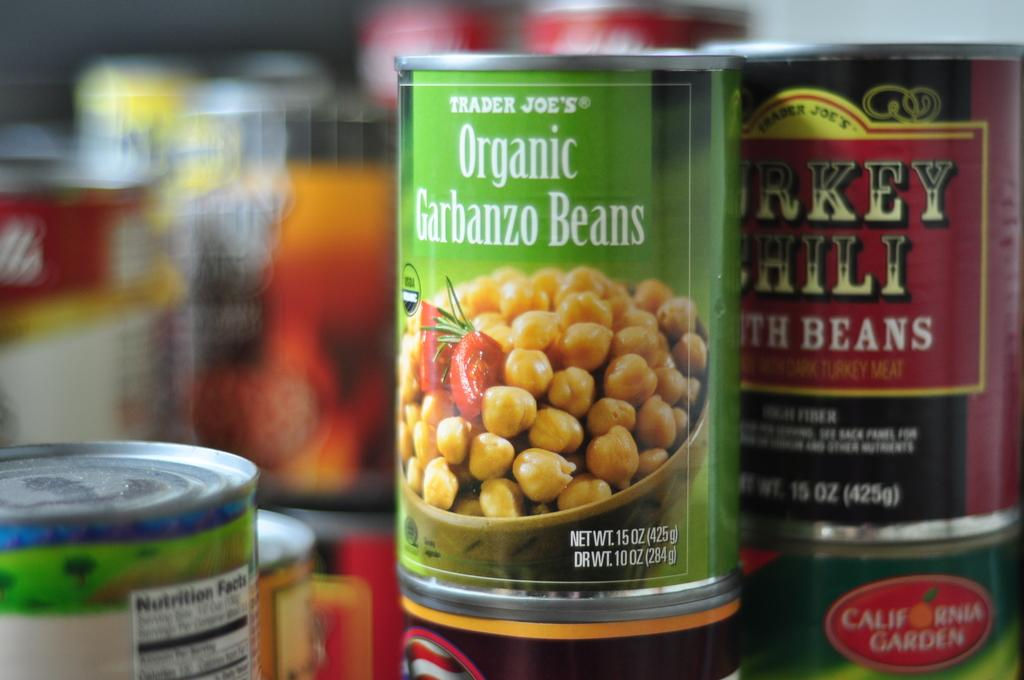What objects are present in the image? There are tins in the image. What can be seen on the surface of the tins? The tins have images and text on them. Can you describe the background of the image? The background of the image is blurry. What type of jam is being stored in the tins in the image? There is no jam present in the image; the tins have images and text on them. How many units of the pig are visible in the image? There are no pigs present in the image. 